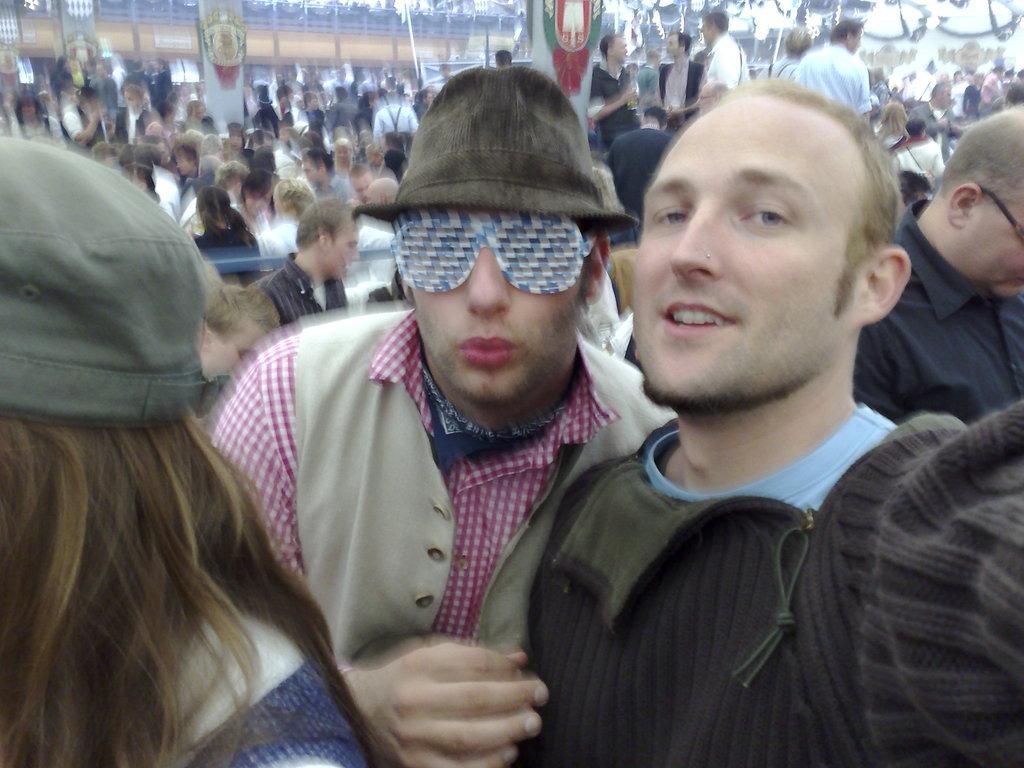In one or two sentences, can you explain what this image depicts? In front of the picture, we see two men are standing. The man on the left side is wearing a hat and the goggles. They are posing for the photo. In front of them, we see a woman who is wearing a cap is standing. Behind them, we see many people are standing. We see the boards in white, green and red color. There are trees and railings in the background. This picture is blurred in the background. 